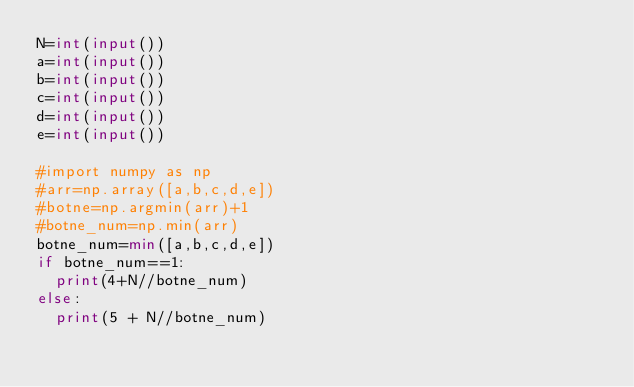<code> <loc_0><loc_0><loc_500><loc_500><_Python_>N=int(input())
a=int(input())
b=int(input())
c=int(input())
d=int(input())
e=int(input())

#import numpy as np
#arr=np.array([a,b,c,d,e])
#botne=np.argmin(arr)+1
#botne_num=np.min(arr)
botne_num=min([a,b,c,d,e])
if botne_num==1:
  print(4+N//botne_num)
else:
  print(5 + N//botne_num)</code> 